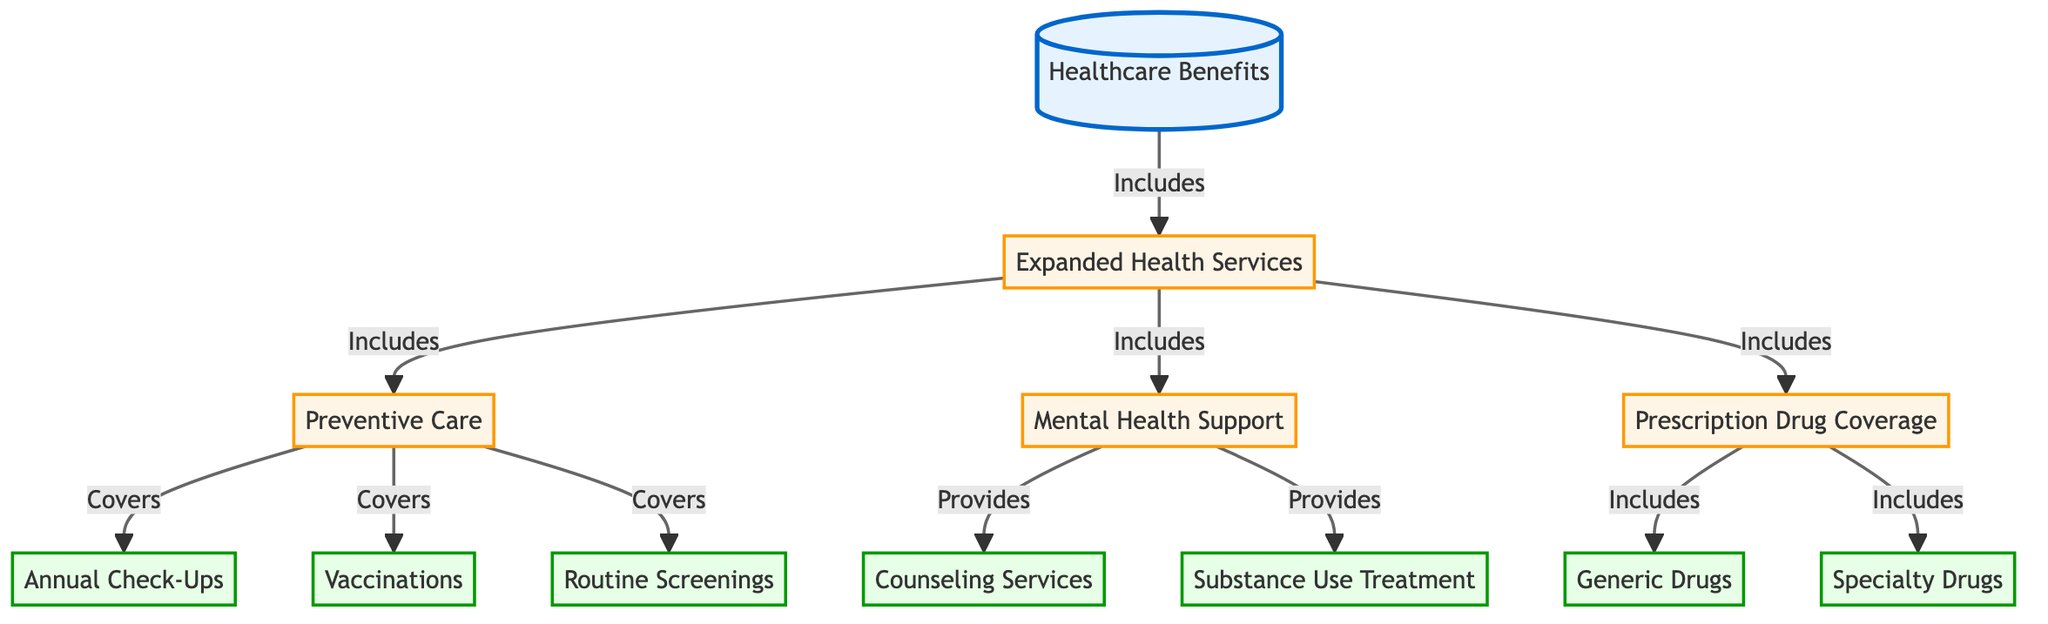What are the main categories of healthcare benefits? The diagram shows "Expanded Health Services" as the main category which includes various subcategories.
Answer: Expanded Health Services How many leaf nodes are present in the diagram? Leaf nodes represent the most specific benefits listed in the diagram. In this case, there are six leaf nodes: Annual Check-Ups, Vaccinations, Routine Screenings, Counseling Services, Substance Use Treatment, Generic Drugs, and Specialty Drugs. Thus, the total count is six.
Answer: 6 What type of care does “Preventive Care” include? The diagram indicates that "Preventive Care" includes three specific services: Annual Check-Ups, Vaccinations, and Routine Screenings. This relationship is explicitly shown in the diagram's structure.
Answer: Annual Check-Ups, Vaccinations, Routine Screenings Which category provides "Counseling Services"? "Counseling Services" is specifically provided under the "Mental Health Support" category, as depicted in the diagram's connection.
Answer: Mental Health Support How many total benefits are included under the “Expanded Health Services” category? “Expanded Health Services” includes Preventive Care, Mental Health Support, and Prescription Drug Coverage. Each of these categories further includes specific benefits. In total, it results in 11 individual benefits when all subcategories are counted.
Answer: 11 What relationship exists between "Prescription Drug Coverage" and "Generic Drugs"? The diagram shows that "Prescription Drug Coverage" includes both "Generic Drugs" and "Specialty Drugs". This indicates a direct inclusion relationship.
Answer: Includes What does "Mental Health Support" provide? The diagram outlines two specific benefits under "Mental Health Support": "Counseling Services" and "Substance Use Treatment". These benefits highlight the focus on mental health within the guidelines.
Answer: Counseling Services, Substance Use Treatment Which node is the starting point of the diagram? The starting point of the diagram is represented by the node labeled “Healthcare Benefits”, which serves as the overarching category for the subsequent benefits outlined.
Answer: Healthcare Benefits How many types of drug coverage are mentioned in the diagram? The diagram specifies two types of drug coverage offered: "Generic Drugs" and "Specialty Drugs", both listed under the "Prescription Drug Coverage" category.
Answer: 2 